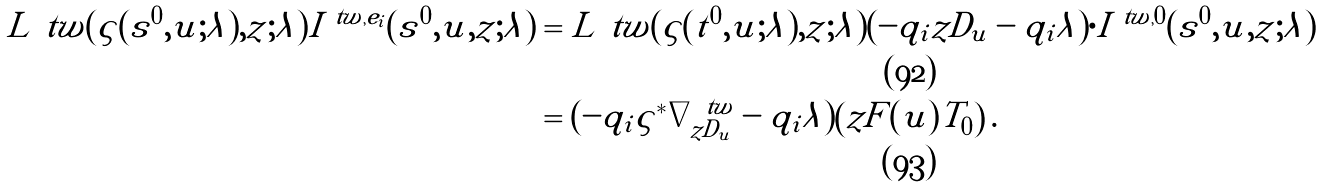Convert formula to latex. <formula><loc_0><loc_0><loc_500><loc_500>L ^ { \ } t w ( \varsigma ( s ^ { 0 } , u ; \lambda ) , z ; \lambda ) I ^ { \ t w , e _ { i } } ( s ^ { 0 } , u , z ; \lambda ) & = L ^ { \ } t w ( \varsigma ( t ^ { 0 } , u ; \lambda ) , z ; \lambda ) ( - q _ { i } z D _ { u } - q _ { i } \lambda ) \cdot I ^ { \ t w , 0 } ( s ^ { 0 } , u , z ; \lambda ) \\ & = ( - q _ { i } \varsigma ^ { * } \nabla ^ { \ t w } _ { z D _ { u } } - q _ { i } \lambda ) \left ( z F ( u ) T _ { 0 } \right ) .</formula> 